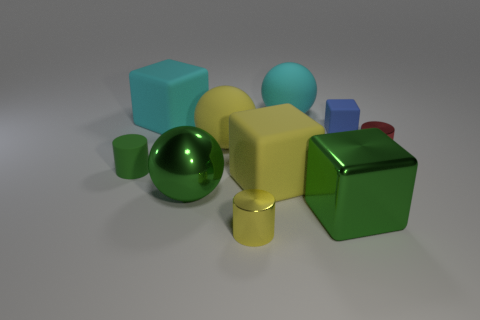How many big cyan matte objects are there?
Keep it short and to the point. 2. What is the color of the other matte object that is the same size as the blue rubber thing?
Ensure brevity in your answer.  Green. Do the cyan rubber cube and the green metal block have the same size?
Offer a terse response. Yes. There is a rubber thing that is the same color as the metallic sphere; what shape is it?
Offer a very short reply. Cylinder. There is a blue object; is it the same size as the cylinder behind the green cylinder?
Offer a terse response. Yes. There is a matte thing that is right of the cyan cube and in front of the red metal cylinder; what is its color?
Your answer should be very brief. Yellow. Are there more big metal balls in front of the large green metal block than large things behind the blue block?
Provide a short and direct response. No. What is the size of the ball that is the same material as the yellow cylinder?
Offer a very short reply. Large. There is a small matte thing that is right of the yellow metallic object; what number of large yellow rubber balls are behind it?
Provide a short and direct response. 0. Are there any small yellow matte objects that have the same shape as the tiny blue object?
Make the answer very short. No. 